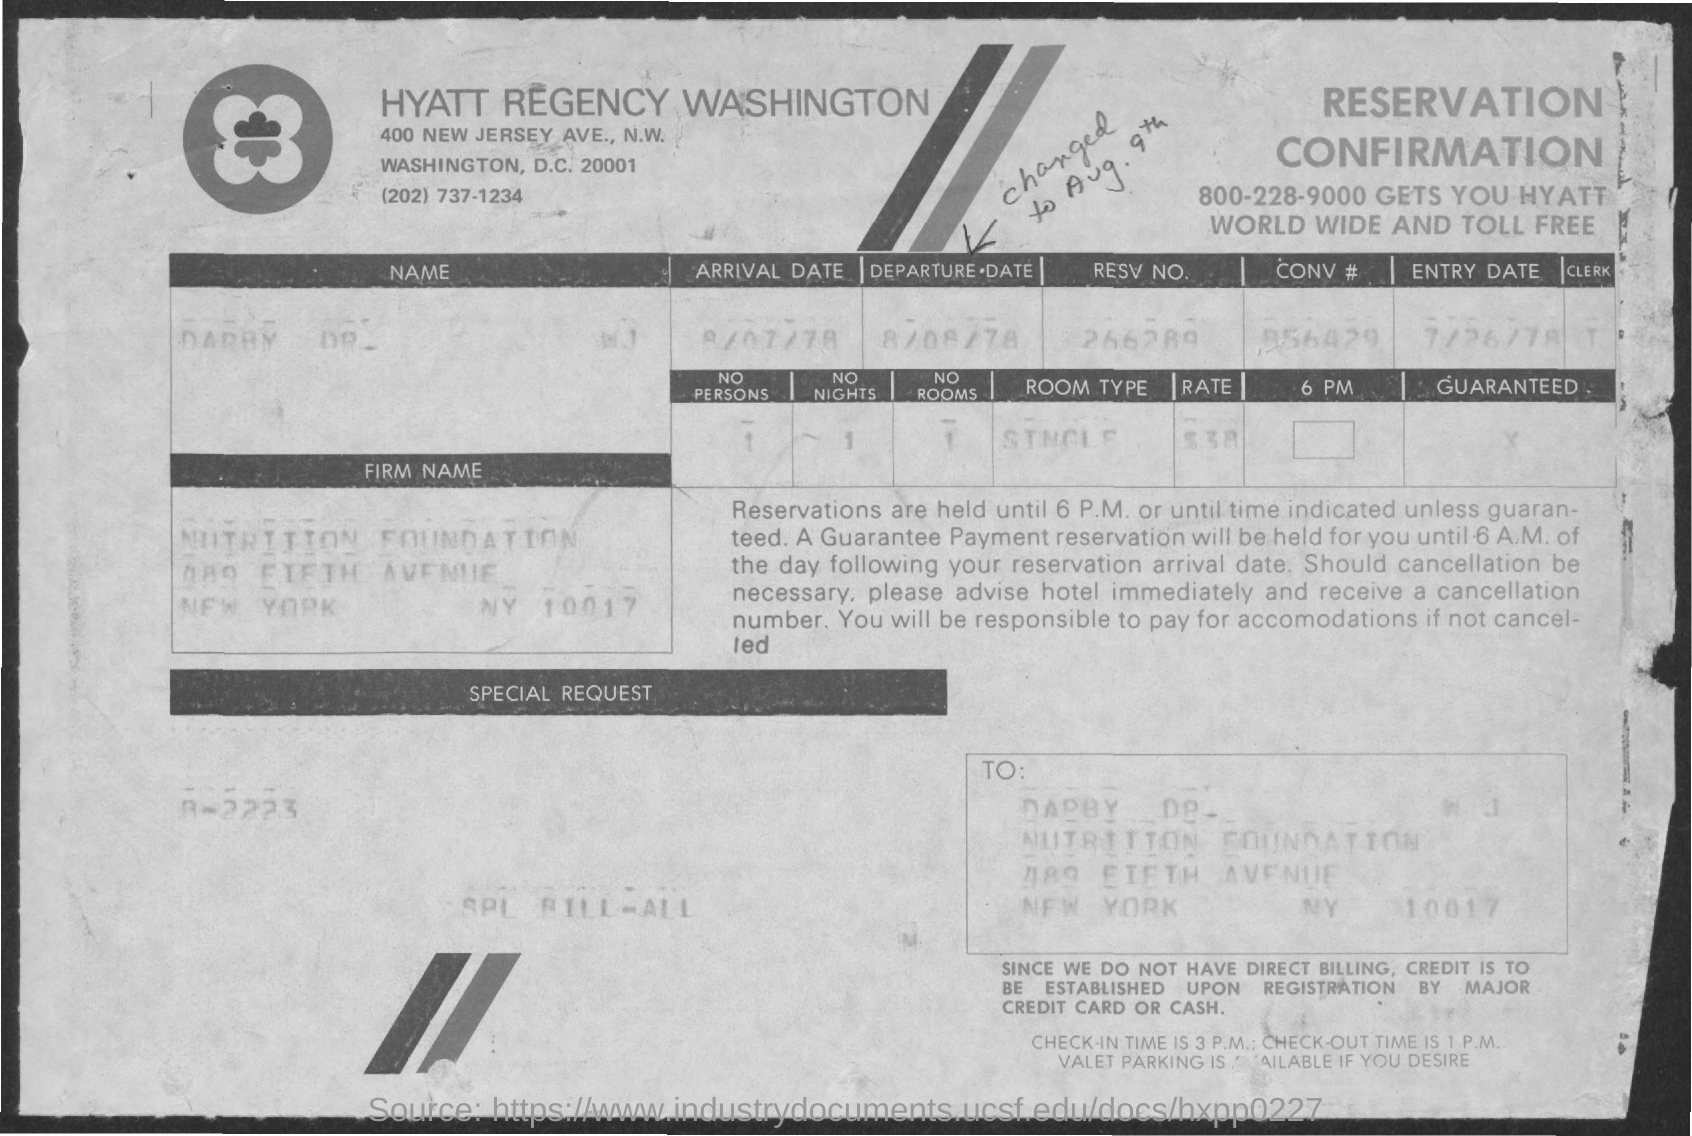What is the entry date mentioned ?
Offer a terse response. 7/26/78. What is the no. persons mentioned ?
Provide a succinct answer. 1. What is the arrival date mentioned ?
Your answer should be very brief. 8/07/78. What is the departure date mentioned ?
Give a very brief answer. 8/08/78. What is the resv. no. mentioned ?
Ensure brevity in your answer.  266289. What is the room type mentioned ?
Keep it short and to the point. Single. 